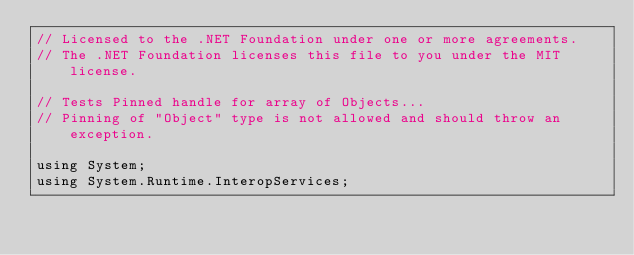<code> <loc_0><loc_0><loc_500><loc_500><_C#_>// Licensed to the .NET Foundation under one or more agreements.
// The .NET Foundation licenses this file to you under the MIT license.

// Tests Pinned handle for array of Objects...
// Pinning of "Object" type is not allowed and should throw an exception.

using System;
using System.Runtime.InteropServices;
</code> 